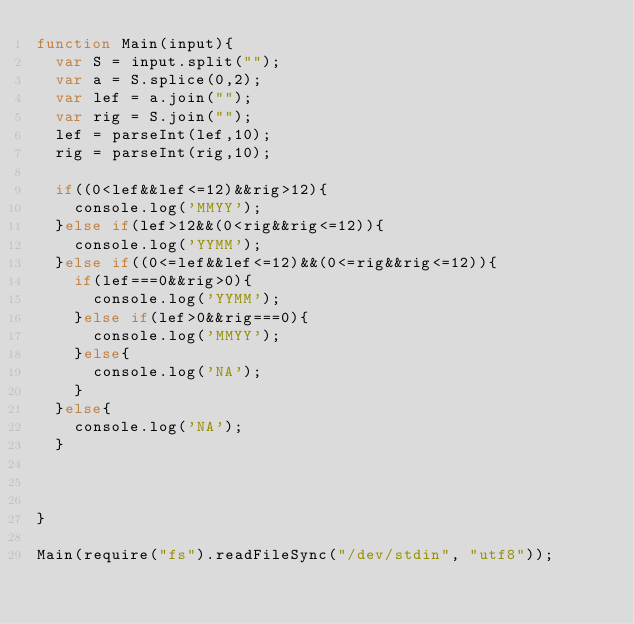<code> <loc_0><loc_0><loc_500><loc_500><_JavaScript_>function Main(input){
  var S = input.split("");
  var a = S.splice(0,2);
  var lef = a.join("");
  var rig = S.join("");
  lef = parseInt(lef,10);
  rig = parseInt(rig,10);
  
  if((0<lef&&lef<=12)&&rig>12){
    console.log('MMYY');
  }else if(lef>12&&(0<rig&&rig<=12)){
    console.log('YYMM');
  }else if((0<=lef&&lef<=12)&&(0<=rig&&rig<=12)){
    if(lef===0&&rig>0){
      console.log('YYMM');
    }else if(lef>0&&rig===0){
      console.log('MMYY');
    }else{
      console.log('NA');
    }
  }else{
    console.log('NA');
  }



}  

Main(require("fs").readFileSync("/dev/stdin", "utf8"));</code> 